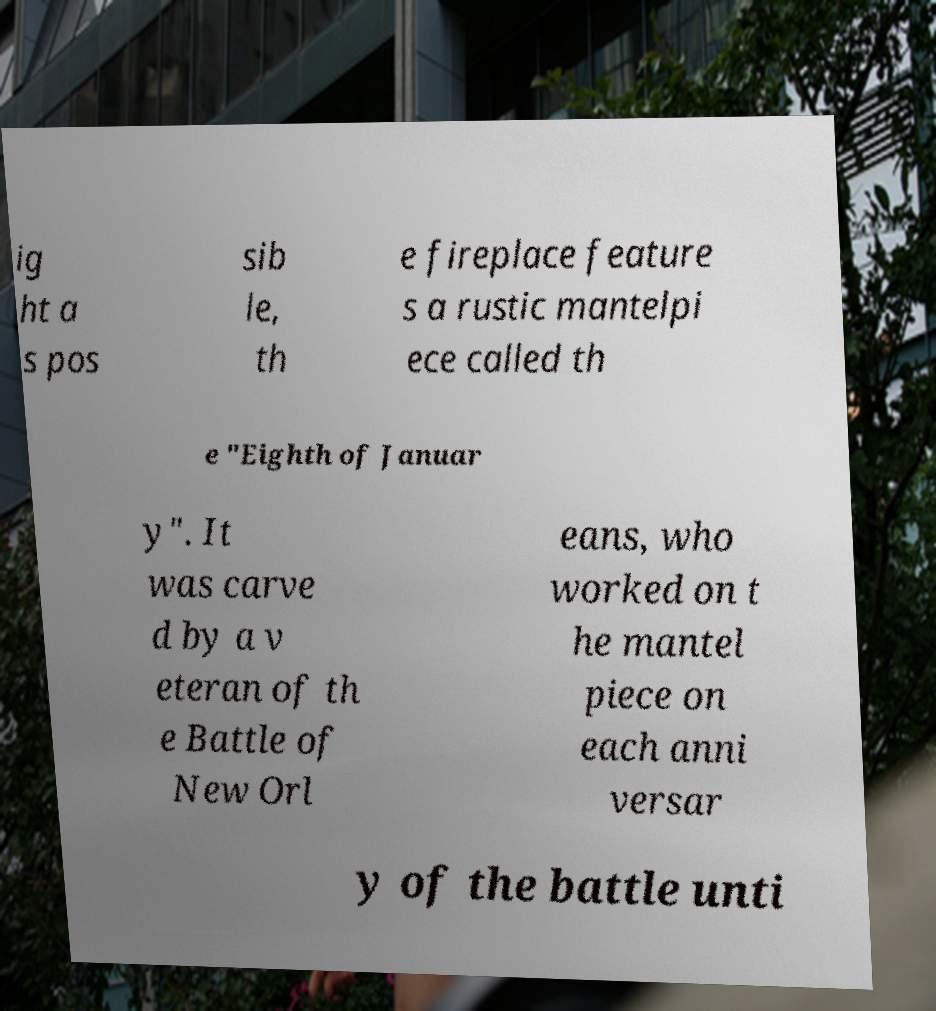I need the written content from this picture converted into text. Can you do that? ig ht a s pos sib le, th e fireplace feature s a rustic mantelpi ece called th e "Eighth of Januar y". It was carve d by a v eteran of th e Battle of New Orl eans, who worked on t he mantel piece on each anni versar y of the battle unti 